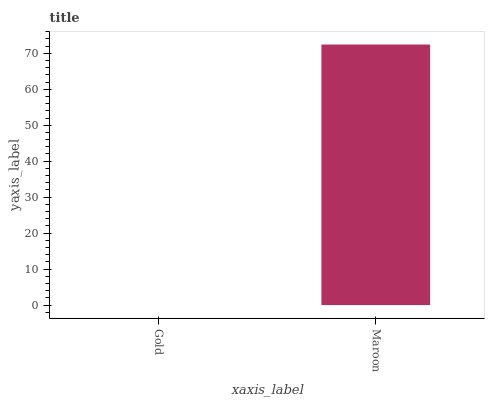Is Maroon the minimum?
Answer yes or no. No. Is Maroon greater than Gold?
Answer yes or no. Yes. Is Gold less than Maroon?
Answer yes or no. Yes. Is Gold greater than Maroon?
Answer yes or no. No. Is Maroon less than Gold?
Answer yes or no. No. Is Maroon the high median?
Answer yes or no. Yes. Is Gold the low median?
Answer yes or no. Yes. Is Gold the high median?
Answer yes or no. No. Is Maroon the low median?
Answer yes or no. No. 